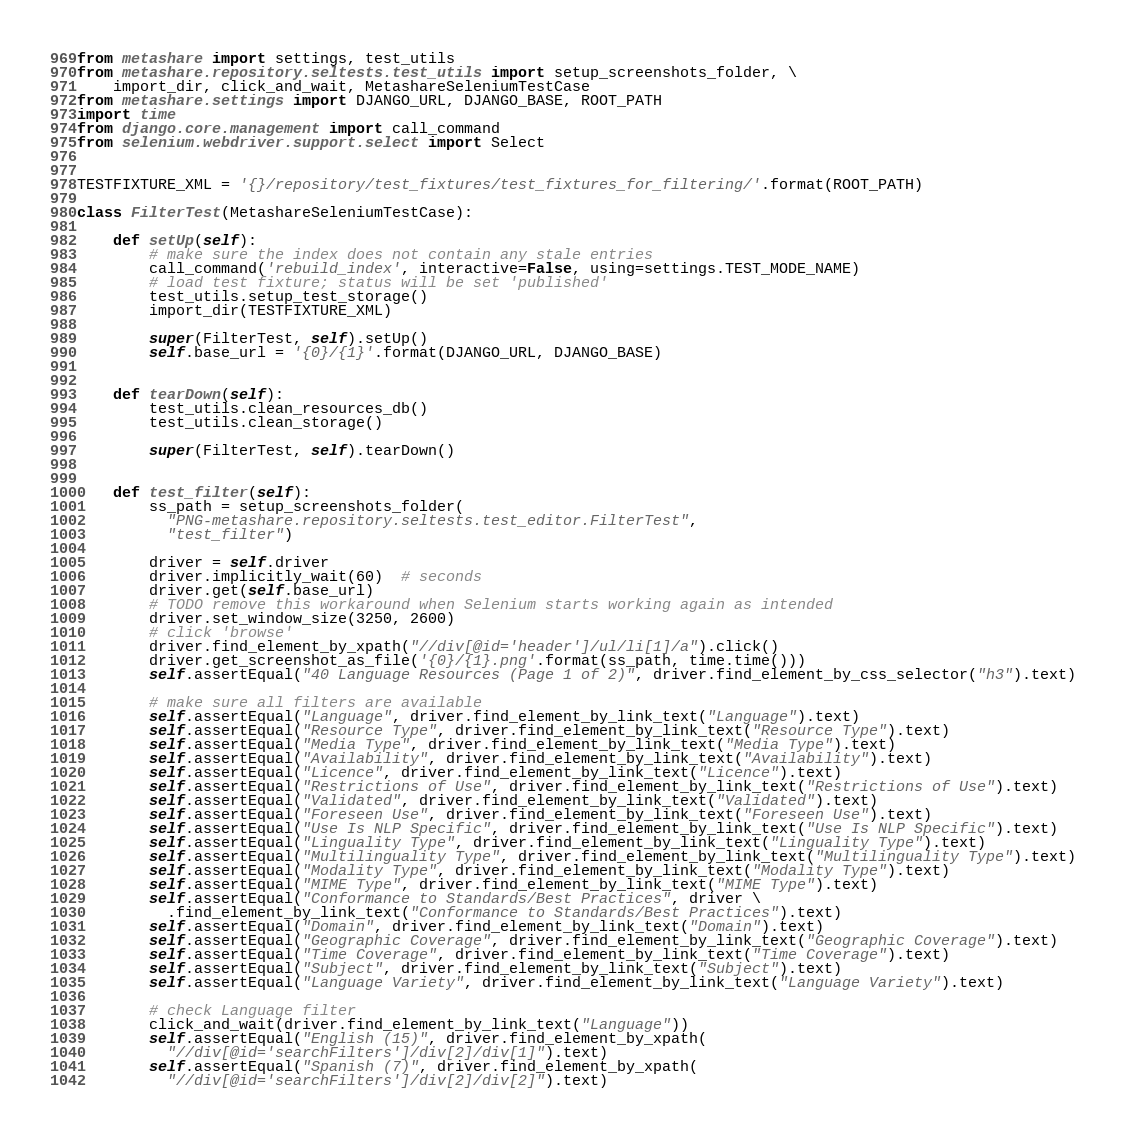Convert code to text. <code><loc_0><loc_0><loc_500><loc_500><_Python_>from metashare import settings, test_utils
from metashare.repository.seltests.test_utils import setup_screenshots_folder, \
    import_dir, click_and_wait, MetashareSeleniumTestCase
from metashare.settings import DJANGO_URL, DJANGO_BASE, ROOT_PATH
import time
from django.core.management import call_command
from selenium.webdriver.support.select import Select


TESTFIXTURE_XML = '{}/repository/test_fixtures/test_fixtures_for_filtering/'.format(ROOT_PATH)

class FilterTest(MetashareSeleniumTestCase):

    def setUp(self):
        # make sure the index does not contain any stale entries
        call_command('rebuild_index', interactive=False, using=settings.TEST_MODE_NAME)
        # load test fixture; status will be set 'published'
        test_utils.setup_test_storage()
        import_dir(TESTFIXTURE_XML)

        super(FilterTest, self).setUp()
        self.base_url = '{0}/{1}'.format(DJANGO_URL, DJANGO_BASE)


    def tearDown(self):
        test_utils.clean_resources_db()
        test_utils.clean_storage()

        super(FilterTest, self).tearDown()


    def test_filter(self):
        ss_path = setup_screenshots_folder(
          "PNG-metashare.repository.seltests.test_editor.FilterTest",
          "test_filter")

        driver = self.driver
        driver.implicitly_wait(60)  # seconds
        driver.get(self.base_url)
        # TODO remove this workaround when Selenium starts working again as intended
        driver.set_window_size(3250, 2600)
        # click 'browse'
        driver.find_element_by_xpath("//div[@id='header']/ul/li[1]/a").click()
        driver.get_screenshot_as_file('{0}/{1}.png'.format(ss_path, time.time()))
        self.assertEqual("40 Language Resources (Page 1 of 2)", driver.find_element_by_css_selector("h3").text)

        # make sure all filters are available
        self.assertEqual("Language", driver.find_element_by_link_text("Language").text)
        self.assertEqual("Resource Type", driver.find_element_by_link_text("Resource Type").text)
        self.assertEqual("Media Type", driver.find_element_by_link_text("Media Type").text)
        self.assertEqual("Availability", driver.find_element_by_link_text("Availability").text)
        self.assertEqual("Licence", driver.find_element_by_link_text("Licence").text)
        self.assertEqual("Restrictions of Use", driver.find_element_by_link_text("Restrictions of Use").text)
        self.assertEqual("Validated", driver.find_element_by_link_text("Validated").text)
        self.assertEqual("Foreseen Use", driver.find_element_by_link_text("Foreseen Use").text)
        self.assertEqual("Use Is NLP Specific", driver.find_element_by_link_text("Use Is NLP Specific").text)
        self.assertEqual("Linguality Type", driver.find_element_by_link_text("Linguality Type").text)
        self.assertEqual("Multilinguality Type", driver.find_element_by_link_text("Multilinguality Type").text)
        self.assertEqual("Modality Type", driver.find_element_by_link_text("Modality Type").text)
        self.assertEqual("MIME Type", driver.find_element_by_link_text("MIME Type").text)
        self.assertEqual("Conformance to Standards/Best Practices", driver \
          .find_element_by_link_text("Conformance to Standards/Best Practices").text)
        self.assertEqual("Domain", driver.find_element_by_link_text("Domain").text)
        self.assertEqual("Geographic Coverage", driver.find_element_by_link_text("Geographic Coverage").text)
        self.assertEqual("Time Coverage", driver.find_element_by_link_text("Time Coverage").text)
        self.assertEqual("Subject", driver.find_element_by_link_text("Subject").text)
        self.assertEqual("Language Variety", driver.find_element_by_link_text("Language Variety").text)

        # check Language filter
        click_and_wait(driver.find_element_by_link_text("Language"))
        self.assertEqual("English (15)", driver.find_element_by_xpath(
          "//div[@id='searchFilters']/div[2]/div[1]").text)
        self.assertEqual("Spanish (7)", driver.find_element_by_xpath(
          "//div[@id='searchFilters']/div[2]/div[2]").text)</code> 